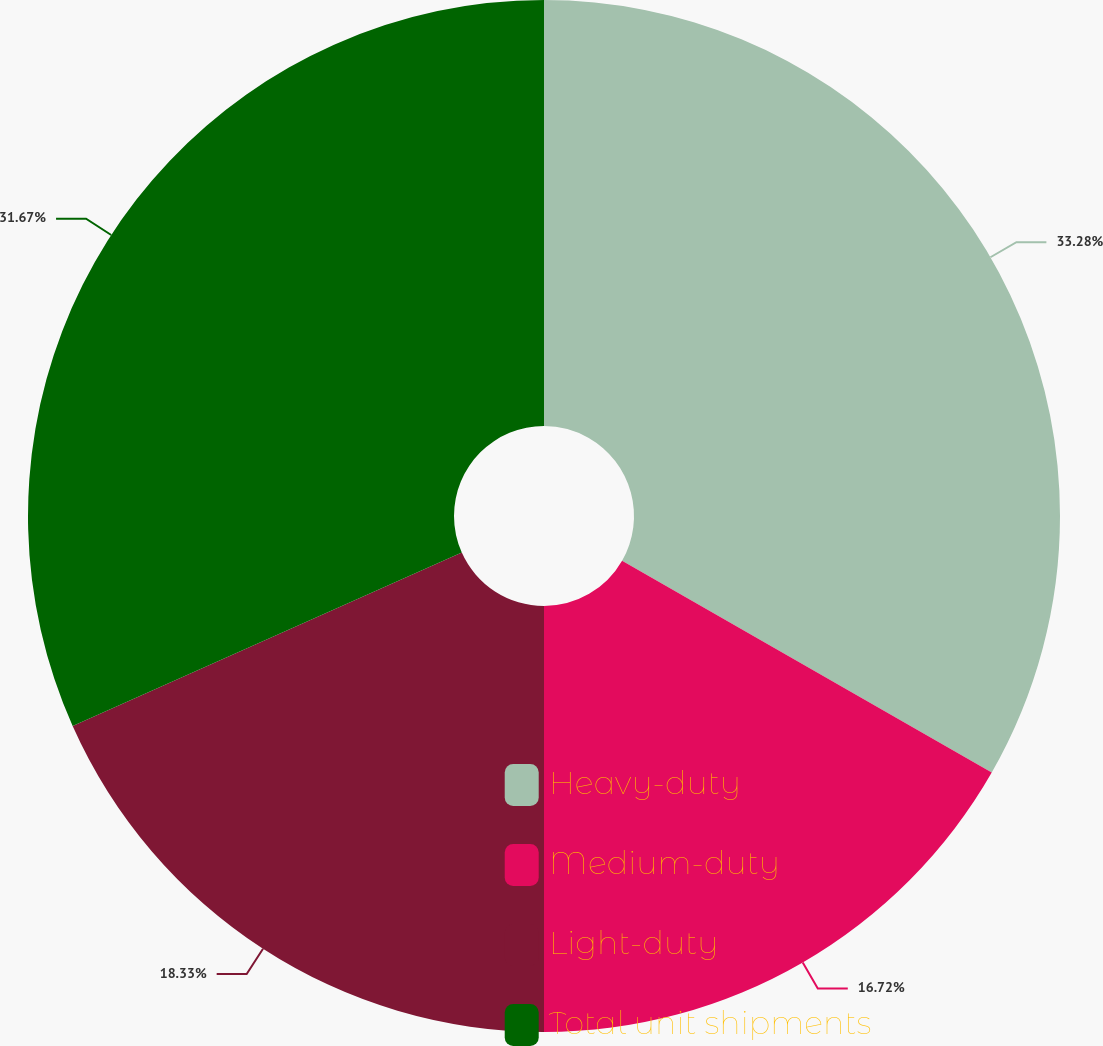Convert chart to OTSL. <chart><loc_0><loc_0><loc_500><loc_500><pie_chart><fcel>Heavy-duty<fcel>Medium-duty<fcel>Light-duty<fcel>Total unit shipments<nl><fcel>33.28%<fcel>16.72%<fcel>18.33%<fcel>31.67%<nl></chart> 